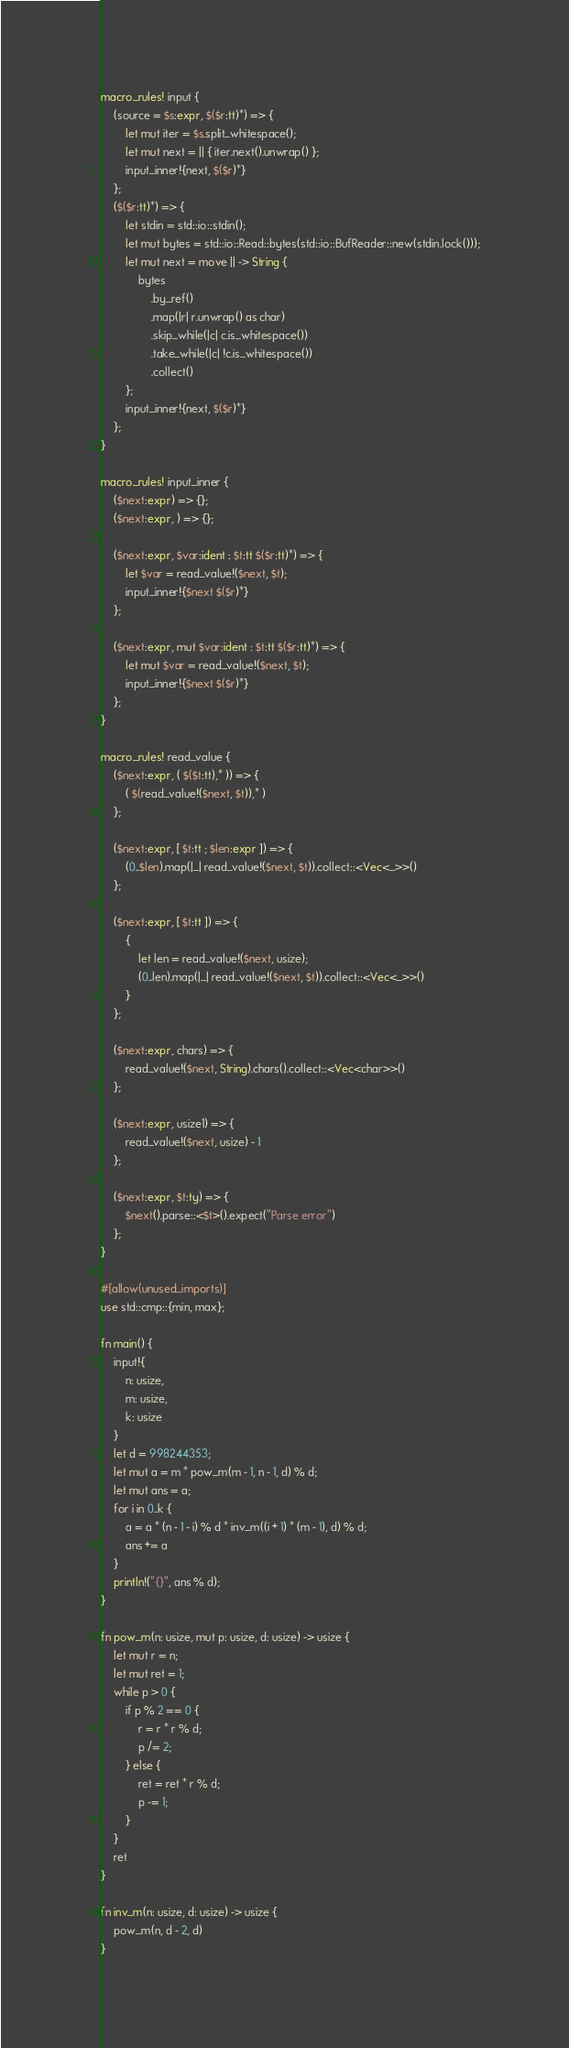<code> <loc_0><loc_0><loc_500><loc_500><_Rust_>macro_rules! input {
    (source = $s:expr, $($r:tt)*) => {
        let mut iter = $s.split_whitespace();
        let mut next = || { iter.next().unwrap() };
        input_inner!{next, $($r)*}
    };
    ($($r:tt)*) => {
        let stdin = std::io::stdin();
        let mut bytes = std::io::Read::bytes(std::io::BufReader::new(stdin.lock()));
        let mut next = move || -> String {
            bytes
                .by_ref()
                .map(|r| r.unwrap() as char)
                .skip_while(|c| c.is_whitespace())
                .take_while(|c| !c.is_whitespace())
                .collect()
        };
        input_inner!{next, $($r)*}
    };
}

macro_rules! input_inner {
    ($next:expr) => {};
    ($next:expr, ) => {};

    ($next:expr, $var:ident : $t:tt $($r:tt)*) => {
        let $var = read_value!($next, $t);
        input_inner!{$next $($r)*}
    };

    ($next:expr, mut $var:ident : $t:tt $($r:tt)*) => {
        let mut $var = read_value!($next, $t);
        input_inner!{$next $($r)*}
    };
}

macro_rules! read_value {
    ($next:expr, ( $($t:tt),* )) => {
        ( $(read_value!($next, $t)),* )
    };

    ($next:expr, [ $t:tt ; $len:expr ]) => {
        (0..$len).map(|_| read_value!($next, $t)).collect::<Vec<_>>()
    };

    ($next:expr, [ $t:tt ]) => {
        {
            let len = read_value!($next, usize);
            (0..len).map(|_| read_value!($next, $t)).collect::<Vec<_>>()
        }
    };

    ($next:expr, chars) => {
        read_value!($next, String).chars().collect::<Vec<char>>()
    };

    ($next:expr, usize1) => {
        read_value!($next, usize) - 1
    };

    ($next:expr, $t:ty) => {
        $next().parse::<$t>().expect("Parse error")
    };
}

#[allow(unused_imports)]
use std::cmp::{min, max};

fn main() {
    input!{
        n: usize,
        m: usize,
        k: usize
    }
    let d = 998244353;
    let mut a = m * pow_m(m - 1, n - 1, d) % d;
    let mut ans = a;
    for i in 0..k {
        a = a * (n - 1 - i) % d * inv_m((i + 1) * (m - 1), d) % d;
        ans += a
    }
    println!("{}", ans % d);
}

fn pow_m(n: usize, mut p: usize, d: usize) -> usize {
    let mut r = n;
    let mut ret = 1;
    while p > 0 {
        if p % 2 == 0 {
            r = r * r % d;
            p /= 2;
        } else {
            ret = ret * r % d;
            p -= 1;
        }
    }
    ret
}

fn inv_m(n: usize, d: usize) -> usize {
    pow_m(n, d - 2, d)
}
</code> 